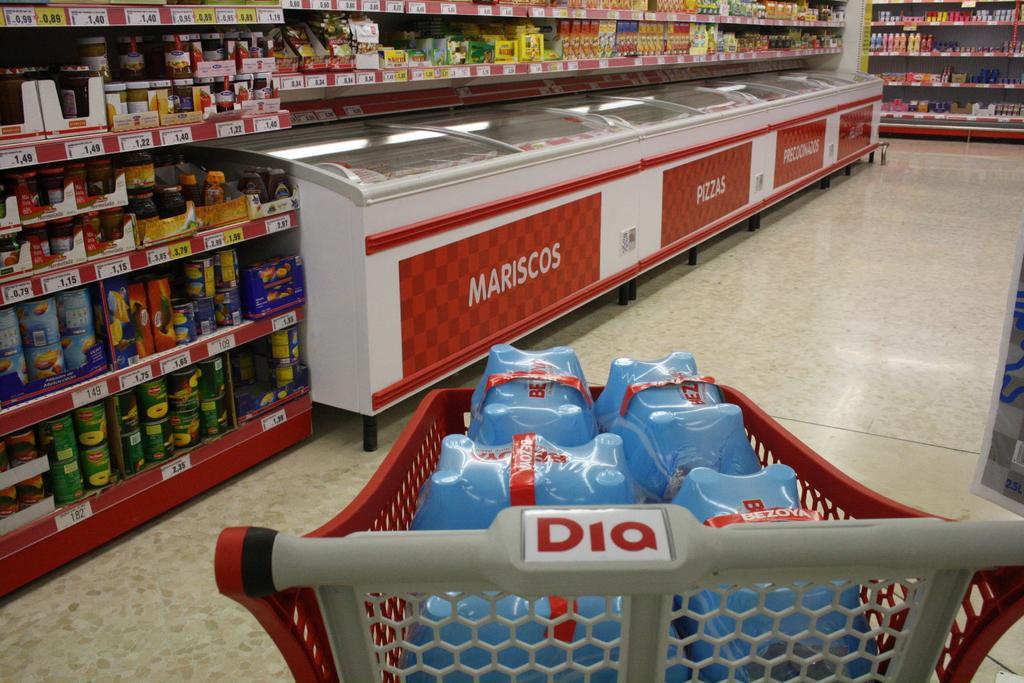<image>
Give a short and clear explanation of the subsequent image. A shopping cart at Dia is full of cases of water. 